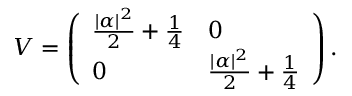<formula> <loc_0><loc_0><loc_500><loc_500>V = \left ( \begin{array} { l l } { \frac { | \alpha | ^ { 2 } } { 2 } + \frac { 1 } { 4 } } & { 0 } \\ { 0 } & { \frac { | \alpha | ^ { 2 } } { 2 } + \frac { 1 } { 4 } } \end{array} \right ) .</formula> 